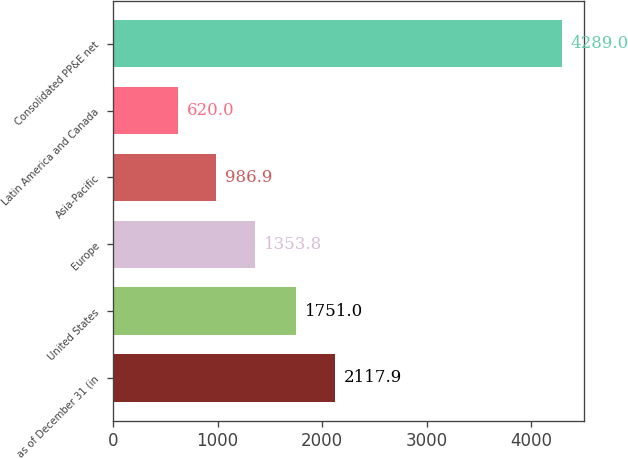Convert chart. <chart><loc_0><loc_0><loc_500><loc_500><bar_chart><fcel>as of December 31 (in<fcel>United States<fcel>Europe<fcel>Asia-Pacific<fcel>Latin America and Canada<fcel>Consolidated PP&E net<nl><fcel>2117.9<fcel>1751<fcel>1353.8<fcel>986.9<fcel>620<fcel>4289<nl></chart> 